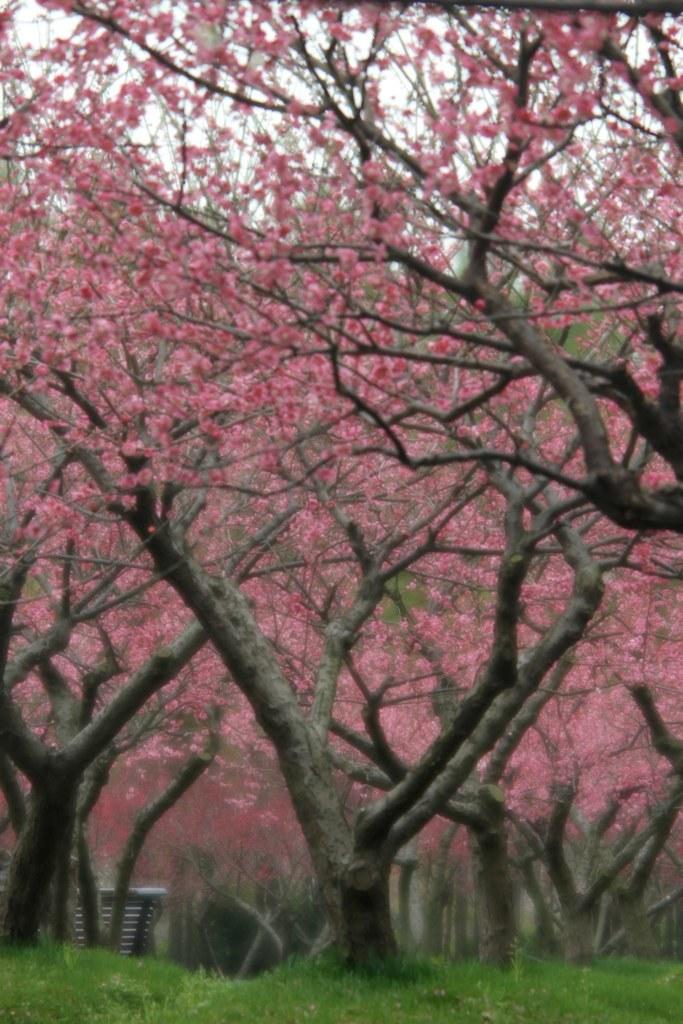What type of terrain is visible in the image? There is an open grass ground in the image. What natural elements can be seen in the image? There are trees and pink flowers present in the image. What is visible at the top of the image? The sky is visible at the top of the image. What type of cushion is being used to work on the grass in the image? There is no cushion or person working on the grass in the image; it only features an open grass ground, trees, pink flowers, and the sky. 